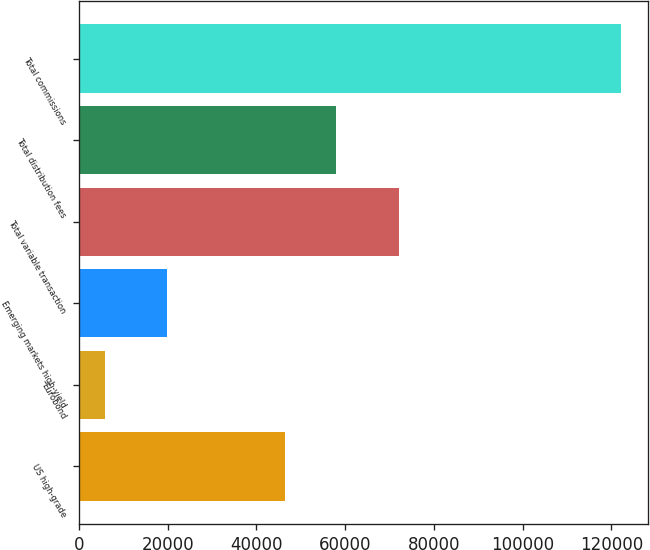Convert chart to OTSL. <chart><loc_0><loc_0><loc_500><loc_500><bar_chart><fcel>US high-grade<fcel>Eurobond<fcel>Emerging markets high-yield<fcel>Total variable transaction<fcel>Total distribution fees<fcel>Total commissions<nl><fcel>46329<fcel>5963<fcel>19728<fcel>72020<fcel>57950.7<fcel>122180<nl></chart> 